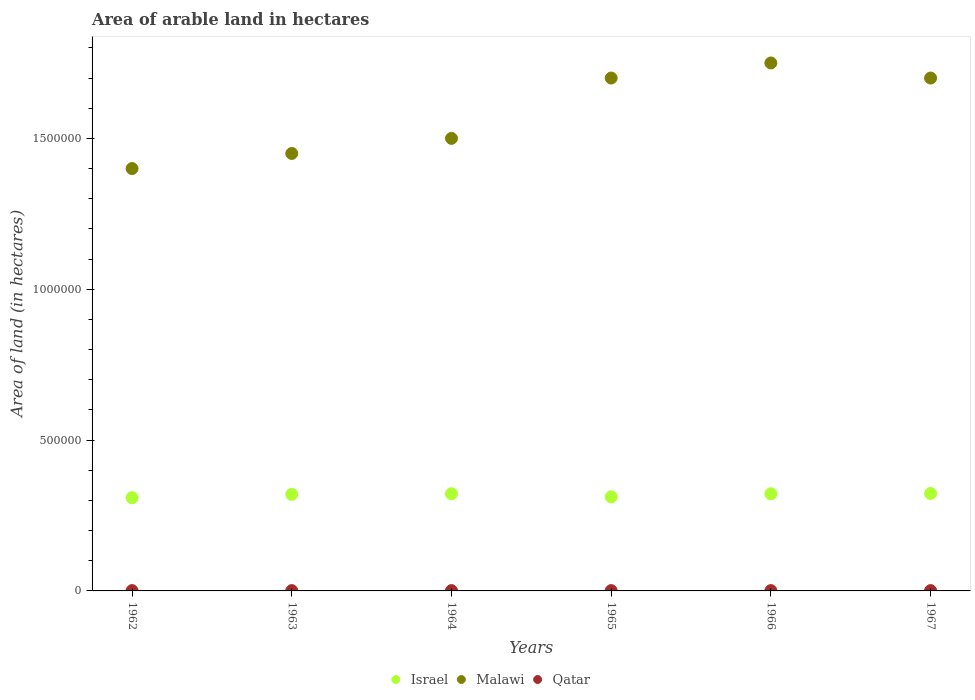Is the number of dotlines equal to the number of legend labels?
Offer a terse response. Yes. What is the total arable land in Malawi in 1964?
Your response must be concise. 1.50e+06. Across all years, what is the maximum total arable land in Qatar?
Keep it short and to the point. 1000. Across all years, what is the minimum total arable land in Malawi?
Ensure brevity in your answer.  1.40e+06. In which year was the total arable land in Malawi maximum?
Provide a succinct answer. 1966. What is the total total arable land in Qatar in the graph?
Ensure brevity in your answer.  6000. What is the difference between the total arable land in Malawi in 1965 and the total arable land in Qatar in 1964?
Your answer should be compact. 1.70e+06. What is the average total arable land in Israel per year?
Give a very brief answer. 3.18e+05. In the year 1962, what is the difference between the total arable land in Malawi and total arable land in Qatar?
Provide a short and direct response. 1.40e+06. In how many years, is the total arable land in Malawi greater than 1400000 hectares?
Give a very brief answer. 5. What is the ratio of the total arable land in Israel in 1962 to that in 1966?
Keep it short and to the point. 0.96. What is the difference between the highest and the lowest total arable land in Israel?
Keep it short and to the point. 1.40e+04. Is the sum of the total arable land in Malawi in 1963 and 1965 greater than the maximum total arable land in Qatar across all years?
Offer a terse response. Yes. Is the total arable land in Israel strictly greater than the total arable land in Malawi over the years?
Your answer should be compact. No. What is the difference between two consecutive major ticks on the Y-axis?
Make the answer very short. 5.00e+05. Are the values on the major ticks of Y-axis written in scientific E-notation?
Ensure brevity in your answer.  No. Does the graph contain grids?
Provide a succinct answer. No. What is the title of the graph?
Provide a short and direct response. Area of arable land in hectares. What is the label or title of the X-axis?
Ensure brevity in your answer.  Years. What is the label or title of the Y-axis?
Offer a very short reply. Area of land (in hectares). What is the Area of land (in hectares) of Israel in 1962?
Ensure brevity in your answer.  3.09e+05. What is the Area of land (in hectares) of Malawi in 1962?
Your answer should be very brief. 1.40e+06. What is the Area of land (in hectares) in Qatar in 1962?
Your answer should be very brief. 1000. What is the Area of land (in hectares) in Malawi in 1963?
Ensure brevity in your answer.  1.45e+06. What is the Area of land (in hectares) of Israel in 1964?
Provide a succinct answer. 3.22e+05. What is the Area of land (in hectares) in Malawi in 1964?
Offer a very short reply. 1.50e+06. What is the Area of land (in hectares) in Qatar in 1964?
Ensure brevity in your answer.  1000. What is the Area of land (in hectares) of Israel in 1965?
Keep it short and to the point. 3.12e+05. What is the Area of land (in hectares) of Malawi in 1965?
Your answer should be compact. 1.70e+06. What is the Area of land (in hectares) in Israel in 1966?
Your response must be concise. 3.22e+05. What is the Area of land (in hectares) of Malawi in 1966?
Offer a terse response. 1.75e+06. What is the Area of land (in hectares) in Israel in 1967?
Your answer should be compact. 3.23e+05. What is the Area of land (in hectares) in Malawi in 1967?
Your answer should be compact. 1.70e+06. Across all years, what is the maximum Area of land (in hectares) of Israel?
Provide a succinct answer. 3.23e+05. Across all years, what is the maximum Area of land (in hectares) of Malawi?
Keep it short and to the point. 1.75e+06. Across all years, what is the maximum Area of land (in hectares) in Qatar?
Provide a short and direct response. 1000. Across all years, what is the minimum Area of land (in hectares) of Israel?
Keep it short and to the point. 3.09e+05. Across all years, what is the minimum Area of land (in hectares) in Malawi?
Make the answer very short. 1.40e+06. Across all years, what is the minimum Area of land (in hectares) in Qatar?
Your answer should be compact. 1000. What is the total Area of land (in hectares) in Israel in the graph?
Make the answer very short. 1.91e+06. What is the total Area of land (in hectares) of Malawi in the graph?
Your response must be concise. 9.50e+06. What is the total Area of land (in hectares) in Qatar in the graph?
Provide a short and direct response. 6000. What is the difference between the Area of land (in hectares) of Israel in 1962 and that in 1963?
Offer a very short reply. -1.10e+04. What is the difference between the Area of land (in hectares) in Qatar in 1962 and that in 1963?
Give a very brief answer. 0. What is the difference between the Area of land (in hectares) of Israel in 1962 and that in 1964?
Offer a very short reply. -1.30e+04. What is the difference between the Area of land (in hectares) of Qatar in 1962 and that in 1964?
Your answer should be compact. 0. What is the difference between the Area of land (in hectares) of Israel in 1962 and that in 1965?
Give a very brief answer. -3000. What is the difference between the Area of land (in hectares) in Israel in 1962 and that in 1966?
Offer a very short reply. -1.30e+04. What is the difference between the Area of land (in hectares) in Malawi in 1962 and that in 1966?
Offer a terse response. -3.50e+05. What is the difference between the Area of land (in hectares) in Israel in 1962 and that in 1967?
Provide a short and direct response. -1.40e+04. What is the difference between the Area of land (in hectares) of Malawi in 1962 and that in 1967?
Give a very brief answer. -3.00e+05. What is the difference between the Area of land (in hectares) of Qatar in 1962 and that in 1967?
Give a very brief answer. 0. What is the difference between the Area of land (in hectares) of Israel in 1963 and that in 1964?
Give a very brief answer. -2000. What is the difference between the Area of land (in hectares) in Qatar in 1963 and that in 1964?
Offer a terse response. 0. What is the difference between the Area of land (in hectares) of Israel in 1963 and that in 1965?
Provide a short and direct response. 8000. What is the difference between the Area of land (in hectares) of Malawi in 1963 and that in 1965?
Keep it short and to the point. -2.50e+05. What is the difference between the Area of land (in hectares) of Israel in 1963 and that in 1966?
Your answer should be compact. -2000. What is the difference between the Area of land (in hectares) of Qatar in 1963 and that in 1966?
Offer a very short reply. 0. What is the difference between the Area of land (in hectares) in Israel in 1963 and that in 1967?
Offer a very short reply. -3000. What is the difference between the Area of land (in hectares) in Malawi in 1963 and that in 1967?
Ensure brevity in your answer.  -2.50e+05. What is the difference between the Area of land (in hectares) in Malawi in 1964 and that in 1965?
Make the answer very short. -2.00e+05. What is the difference between the Area of land (in hectares) of Malawi in 1964 and that in 1966?
Provide a short and direct response. -2.50e+05. What is the difference between the Area of land (in hectares) of Qatar in 1964 and that in 1966?
Your response must be concise. 0. What is the difference between the Area of land (in hectares) of Israel in 1964 and that in 1967?
Make the answer very short. -1000. What is the difference between the Area of land (in hectares) in Qatar in 1964 and that in 1967?
Make the answer very short. 0. What is the difference between the Area of land (in hectares) in Israel in 1965 and that in 1966?
Keep it short and to the point. -10000. What is the difference between the Area of land (in hectares) of Malawi in 1965 and that in 1966?
Give a very brief answer. -5.00e+04. What is the difference between the Area of land (in hectares) in Qatar in 1965 and that in 1966?
Keep it short and to the point. 0. What is the difference between the Area of land (in hectares) of Israel in 1965 and that in 1967?
Keep it short and to the point. -1.10e+04. What is the difference between the Area of land (in hectares) in Qatar in 1965 and that in 1967?
Your answer should be very brief. 0. What is the difference between the Area of land (in hectares) of Israel in 1966 and that in 1967?
Provide a succinct answer. -1000. What is the difference between the Area of land (in hectares) in Qatar in 1966 and that in 1967?
Provide a short and direct response. 0. What is the difference between the Area of land (in hectares) of Israel in 1962 and the Area of land (in hectares) of Malawi in 1963?
Keep it short and to the point. -1.14e+06. What is the difference between the Area of land (in hectares) in Israel in 1962 and the Area of land (in hectares) in Qatar in 1963?
Offer a very short reply. 3.08e+05. What is the difference between the Area of land (in hectares) in Malawi in 1962 and the Area of land (in hectares) in Qatar in 1963?
Your response must be concise. 1.40e+06. What is the difference between the Area of land (in hectares) of Israel in 1962 and the Area of land (in hectares) of Malawi in 1964?
Your response must be concise. -1.19e+06. What is the difference between the Area of land (in hectares) in Israel in 1962 and the Area of land (in hectares) in Qatar in 1964?
Your answer should be very brief. 3.08e+05. What is the difference between the Area of land (in hectares) of Malawi in 1962 and the Area of land (in hectares) of Qatar in 1964?
Provide a short and direct response. 1.40e+06. What is the difference between the Area of land (in hectares) of Israel in 1962 and the Area of land (in hectares) of Malawi in 1965?
Your answer should be very brief. -1.39e+06. What is the difference between the Area of land (in hectares) in Israel in 1962 and the Area of land (in hectares) in Qatar in 1965?
Provide a short and direct response. 3.08e+05. What is the difference between the Area of land (in hectares) in Malawi in 1962 and the Area of land (in hectares) in Qatar in 1965?
Provide a succinct answer. 1.40e+06. What is the difference between the Area of land (in hectares) of Israel in 1962 and the Area of land (in hectares) of Malawi in 1966?
Provide a succinct answer. -1.44e+06. What is the difference between the Area of land (in hectares) of Israel in 1962 and the Area of land (in hectares) of Qatar in 1966?
Provide a short and direct response. 3.08e+05. What is the difference between the Area of land (in hectares) of Malawi in 1962 and the Area of land (in hectares) of Qatar in 1966?
Provide a short and direct response. 1.40e+06. What is the difference between the Area of land (in hectares) of Israel in 1962 and the Area of land (in hectares) of Malawi in 1967?
Give a very brief answer. -1.39e+06. What is the difference between the Area of land (in hectares) of Israel in 1962 and the Area of land (in hectares) of Qatar in 1967?
Your response must be concise. 3.08e+05. What is the difference between the Area of land (in hectares) in Malawi in 1962 and the Area of land (in hectares) in Qatar in 1967?
Provide a succinct answer. 1.40e+06. What is the difference between the Area of land (in hectares) in Israel in 1963 and the Area of land (in hectares) in Malawi in 1964?
Provide a succinct answer. -1.18e+06. What is the difference between the Area of land (in hectares) of Israel in 1963 and the Area of land (in hectares) of Qatar in 1964?
Your answer should be compact. 3.19e+05. What is the difference between the Area of land (in hectares) of Malawi in 1963 and the Area of land (in hectares) of Qatar in 1964?
Your answer should be very brief. 1.45e+06. What is the difference between the Area of land (in hectares) in Israel in 1963 and the Area of land (in hectares) in Malawi in 1965?
Provide a short and direct response. -1.38e+06. What is the difference between the Area of land (in hectares) of Israel in 1963 and the Area of land (in hectares) of Qatar in 1965?
Your answer should be compact. 3.19e+05. What is the difference between the Area of land (in hectares) of Malawi in 1963 and the Area of land (in hectares) of Qatar in 1965?
Your response must be concise. 1.45e+06. What is the difference between the Area of land (in hectares) in Israel in 1963 and the Area of land (in hectares) in Malawi in 1966?
Your response must be concise. -1.43e+06. What is the difference between the Area of land (in hectares) in Israel in 1963 and the Area of land (in hectares) in Qatar in 1966?
Your answer should be compact. 3.19e+05. What is the difference between the Area of land (in hectares) in Malawi in 1963 and the Area of land (in hectares) in Qatar in 1966?
Provide a succinct answer. 1.45e+06. What is the difference between the Area of land (in hectares) in Israel in 1963 and the Area of land (in hectares) in Malawi in 1967?
Give a very brief answer. -1.38e+06. What is the difference between the Area of land (in hectares) in Israel in 1963 and the Area of land (in hectares) in Qatar in 1967?
Offer a very short reply. 3.19e+05. What is the difference between the Area of land (in hectares) of Malawi in 1963 and the Area of land (in hectares) of Qatar in 1967?
Ensure brevity in your answer.  1.45e+06. What is the difference between the Area of land (in hectares) of Israel in 1964 and the Area of land (in hectares) of Malawi in 1965?
Provide a succinct answer. -1.38e+06. What is the difference between the Area of land (in hectares) of Israel in 1964 and the Area of land (in hectares) of Qatar in 1965?
Provide a succinct answer. 3.21e+05. What is the difference between the Area of land (in hectares) in Malawi in 1964 and the Area of land (in hectares) in Qatar in 1965?
Provide a short and direct response. 1.50e+06. What is the difference between the Area of land (in hectares) in Israel in 1964 and the Area of land (in hectares) in Malawi in 1966?
Provide a succinct answer. -1.43e+06. What is the difference between the Area of land (in hectares) of Israel in 1964 and the Area of land (in hectares) of Qatar in 1966?
Give a very brief answer. 3.21e+05. What is the difference between the Area of land (in hectares) in Malawi in 1964 and the Area of land (in hectares) in Qatar in 1966?
Your answer should be very brief. 1.50e+06. What is the difference between the Area of land (in hectares) in Israel in 1964 and the Area of land (in hectares) in Malawi in 1967?
Provide a short and direct response. -1.38e+06. What is the difference between the Area of land (in hectares) in Israel in 1964 and the Area of land (in hectares) in Qatar in 1967?
Provide a short and direct response. 3.21e+05. What is the difference between the Area of land (in hectares) of Malawi in 1964 and the Area of land (in hectares) of Qatar in 1967?
Provide a short and direct response. 1.50e+06. What is the difference between the Area of land (in hectares) in Israel in 1965 and the Area of land (in hectares) in Malawi in 1966?
Make the answer very short. -1.44e+06. What is the difference between the Area of land (in hectares) in Israel in 1965 and the Area of land (in hectares) in Qatar in 1966?
Make the answer very short. 3.11e+05. What is the difference between the Area of land (in hectares) in Malawi in 1965 and the Area of land (in hectares) in Qatar in 1966?
Your answer should be compact. 1.70e+06. What is the difference between the Area of land (in hectares) of Israel in 1965 and the Area of land (in hectares) of Malawi in 1967?
Your response must be concise. -1.39e+06. What is the difference between the Area of land (in hectares) in Israel in 1965 and the Area of land (in hectares) in Qatar in 1967?
Keep it short and to the point. 3.11e+05. What is the difference between the Area of land (in hectares) of Malawi in 1965 and the Area of land (in hectares) of Qatar in 1967?
Offer a terse response. 1.70e+06. What is the difference between the Area of land (in hectares) of Israel in 1966 and the Area of land (in hectares) of Malawi in 1967?
Ensure brevity in your answer.  -1.38e+06. What is the difference between the Area of land (in hectares) in Israel in 1966 and the Area of land (in hectares) in Qatar in 1967?
Offer a terse response. 3.21e+05. What is the difference between the Area of land (in hectares) in Malawi in 1966 and the Area of land (in hectares) in Qatar in 1967?
Ensure brevity in your answer.  1.75e+06. What is the average Area of land (in hectares) in Israel per year?
Your answer should be very brief. 3.18e+05. What is the average Area of land (in hectares) of Malawi per year?
Your answer should be compact. 1.58e+06. In the year 1962, what is the difference between the Area of land (in hectares) of Israel and Area of land (in hectares) of Malawi?
Offer a very short reply. -1.09e+06. In the year 1962, what is the difference between the Area of land (in hectares) of Israel and Area of land (in hectares) of Qatar?
Your answer should be very brief. 3.08e+05. In the year 1962, what is the difference between the Area of land (in hectares) in Malawi and Area of land (in hectares) in Qatar?
Offer a very short reply. 1.40e+06. In the year 1963, what is the difference between the Area of land (in hectares) of Israel and Area of land (in hectares) of Malawi?
Make the answer very short. -1.13e+06. In the year 1963, what is the difference between the Area of land (in hectares) in Israel and Area of land (in hectares) in Qatar?
Offer a very short reply. 3.19e+05. In the year 1963, what is the difference between the Area of land (in hectares) in Malawi and Area of land (in hectares) in Qatar?
Provide a succinct answer. 1.45e+06. In the year 1964, what is the difference between the Area of land (in hectares) in Israel and Area of land (in hectares) in Malawi?
Make the answer very short. -1.18e+06. In the year 1964, what is the difference between the Area of land (in hectares) of Israel and Area of land (in hectares) of Qatar?
Offer a terse response. 3.21e+05. In the year 1964, what is the difference between the Area of land (in hectares) of Malawi and Area of land (in hectares) of Qatar?
Keep it short and to the point. 1.50e+06. In the year 1965, what is the difference between the Area of land (in hectares) of Israel and Area of land (in hectares) of Malawi?
Provide a succinct answer. -1.39e+06. In the year 1965, what is the difference between the Area of land (in hectares) of Israel and Area of land (in hectares) of Qatar?
Your response must be concise. 3.11e+05. In the year 1965, what is the difference between the Area of land (in hectares) in Malawi and Area of land (in hectares) in Qatar?
Offer a terse response. 1.70e+06. In the year 1966, what is the difference between the Area of land (in hectares) of Israel and Area of land (in hectares) of Malawi?
Keep it short and to the point. -1.43e+06. In the year 1966, what is the difference between the Area of land (in hectares) in Israel and Area of land (in hectares) in Qatar?
Offer a terse response. 3.21e+05. In the year 1966, what is the difference between the Area of land (in hectares) of Malawi and Area of land (in hectares) of Qatar?
Your answer should be compact. 1.75e+06. In the year 1967, what is the difference between the Area of land (in hectares) of Israel and Area of land (in hectares) of Malawi?
Offer a very short reply. -1.38e+06. In the year 1967, what is the difference between the Area of land (in hectares) of Israel and Area of land (in hectares) of Qatar?
Offer a very short reply. 3.22e+05. In the year 1967, what is the difference between the Area of land (in hectares) of Malawi and Area of land (in hectares) of Qatar?
Your response must be concise. 1.70e+06. What is the ratio of the Area of land (in hectares) in Israel in 1962 to that in 1963?
Provide a succinct answer. 0.97. What is the ratio of the Area of land (in hectares) in Malawi in 1962 to that in 1963?
Make the answer very short. 0.97. What is the ratio of the Area of land (in hectares) of Israel in 1962 to that in 1964?
Your response must be concise. 0.96. What is the ratio of the Area of land (in hectares) in Malawi in 1962 to that in 1964?
Your answer should be compact. 0.93. What is the ratio of the Area of land (in hectares) of Israel in 1962 to that in 1965?
Offer a terse response. 0.99. What is the ratio of the Area of land (in hectares) in Malawi in 1962 to that in 1965?
Provide a succinct answer. 0.82. What is the ratio of the Area of land (in hectares) of Israel in 1962 to that in 1966?
Keep it short and to the point. 0.96. What is the ratio of the Area of land (in hectares) in Malawi in 1962 to that in 1966?
Your answer should be compact. 0.8. What is the ratio of the Area of land (in hectares) of Qatar in 1962 to that in 1966?
Offer a very short reply. 1. What is the ratio of the Area of land (in hectares) in Israel in 1962 to that in 1967?
Your answer should be very brief. 0.96. What is the ratio of the Area of land (in hectares) in Malawi in 1962 to that in 1967?
Your response must be concise. 0.82. What is the ratio of the Area of land (in hectares) in Israel in 1963 to that in 1964?
Provide a succinct answer. 0.99. What is the ratio of the Area of land (in hectares) of Malawi in 1963 to that in 1964?
Give a very brief answer. 0.97. What is the ratio of the Area of land (in hectares) of Qatar in 1963 to that in 1964?
Give a very brief answer. 1. What is the ratio of the Area of land (in hectares) in Israel in 1963 to that in 1965?
Make the answer very short. 1.03. What is the ratio of the Area of land (in hectares) of Malawi in 1963 to that in 1965?
Provide a short and direct response. 0.85. What is the ratio of the Area of land (in hectares) of Qatar in 1963 to that in 1965?
Give a very brief answer. 1. What is the ratio of the Area of land (in hectares) of Malawi in 1963 to that in 1966?
Provide a short and direct response. 0.83. What is the ratio of the Area of land (in hectares) in Qatar in 1963 to that in 1966?
Ensure brevity in your answer.  1. What is the ratio of the Area of land (in hectares) of Malawi in 1963 to that in 1967?
Your answer should be compact. 0.85. What is the ratio of the Area of land (in hectares) of Israel in 1964 to that in 1965?
Offer a terse response. 1.03. What is the ratio of the Area of land (in hectares) in Malawi in 1964 to that in 1965?
Keep it short and to the point. 0.88. What is the ratio of the Area of land (in hectares) in Malawi in 1964 to that in 1966?
Your answer should be compact. 0.86. What is the ratio of the Area of land (in hectares) of Qatar in 1964 to that in 1966?
Make the answer very short. 1. What is the ratio of the Area of land (in hectares) of Israel in 1964 to that in 1967?
Make the answer very short. 1. What is the ratio of the Area of land (in hectares) of Malawi in 1964 to that in 1967?
Ensure brevity in your answer.  0.88. What is the ratio of the Area of land (in hectares) of Israel in 1965 to that in 1966?
Ensure brevity in your answer.  0.97. What is the ratio of the Area of land (in hectares) of Malawi in 1965 to that in 1966?
Give a very brief answer. 0.97. What is the ratio of the Area of land (in hectares) of Qatar in 1965 to that in 1966?
Keep it short and to the point. 1. What is the ratio of the Area of land (in hectares) in Israel in 1965 to that in 1967?
Your answer should be very brief. 0.97. What is the ratio of the Area of land (in hectares) in Malawi in 1965 to that in 1967?
Your response must be concise. 1. What is the ratio of the Area of land (in hectares) in Qatar in 1965 to that in 1967?
Your response must be concise. 1. What is the ratio of the Area of land (in hectares) in Israel in 1966 to that in 1967?
Keep it short and to the point. 1. What is the ratio of the Area of land (in hectares) of Malawi in 1966 to that in 1967?
Provide a short and direct response. 1.03. What is the ratio of the Area of land (in hectares) of Qatar in 1966 to that in 1967?
Offer a very short reply. 1. What is the difference between the highest and the second highest Area of land (in hectares) in Israel?
Provide a succinct answer. 1000. What is the difference between the highest and the second highest Area of land (in hectares) of Malawi?
Offer a terse response. 5.00e+04. What is the difference between the highest and the lowest Area of land (in hectares) of Israel?
Provide a short and direct response. 1.40e+04. What is the difference between the highest and the lowest Area of land (in hectares) in Malawi?
Provide a succinct answer. 3.50e+05. 